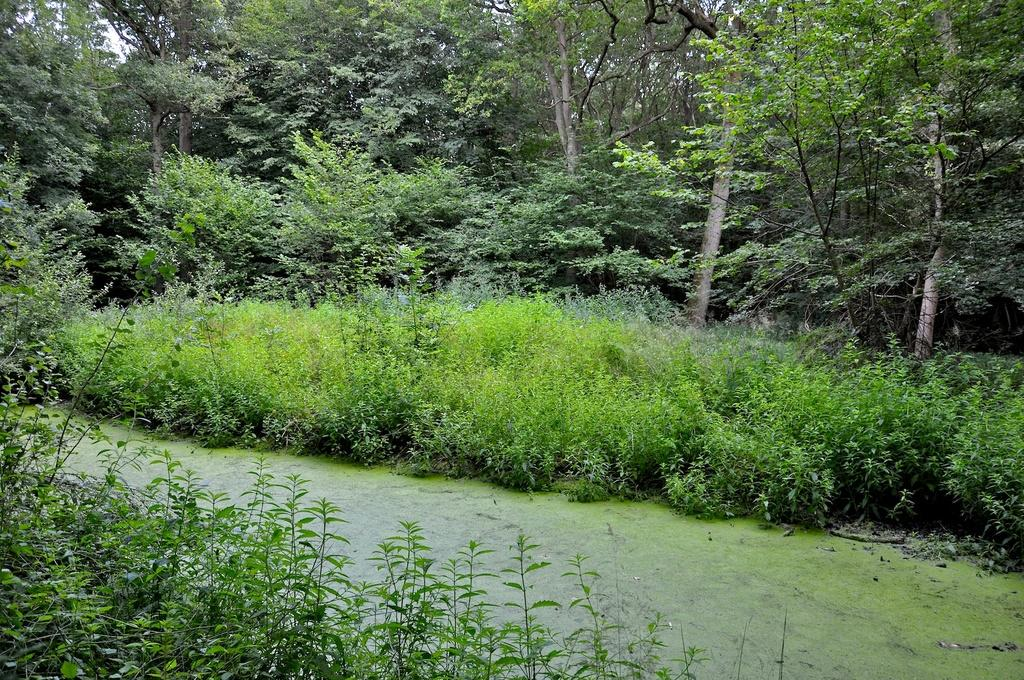What is the primary element visible in the picture? There is water in the picture. What is growing on the water in the picture? There is algae on the water. What type of vegetation can be seen in the picture? There are plants and trees in the picture. How would you describe the sky in the picture? The sky is clear in the picture. What type of system is being used to collect water in the picture? There is no system visible in the picture for collecting water. Can you tell me what the trees are acting in the picture? Trees are not actors and do not perform actions in the picture; they are simply part of the natural landscape. 